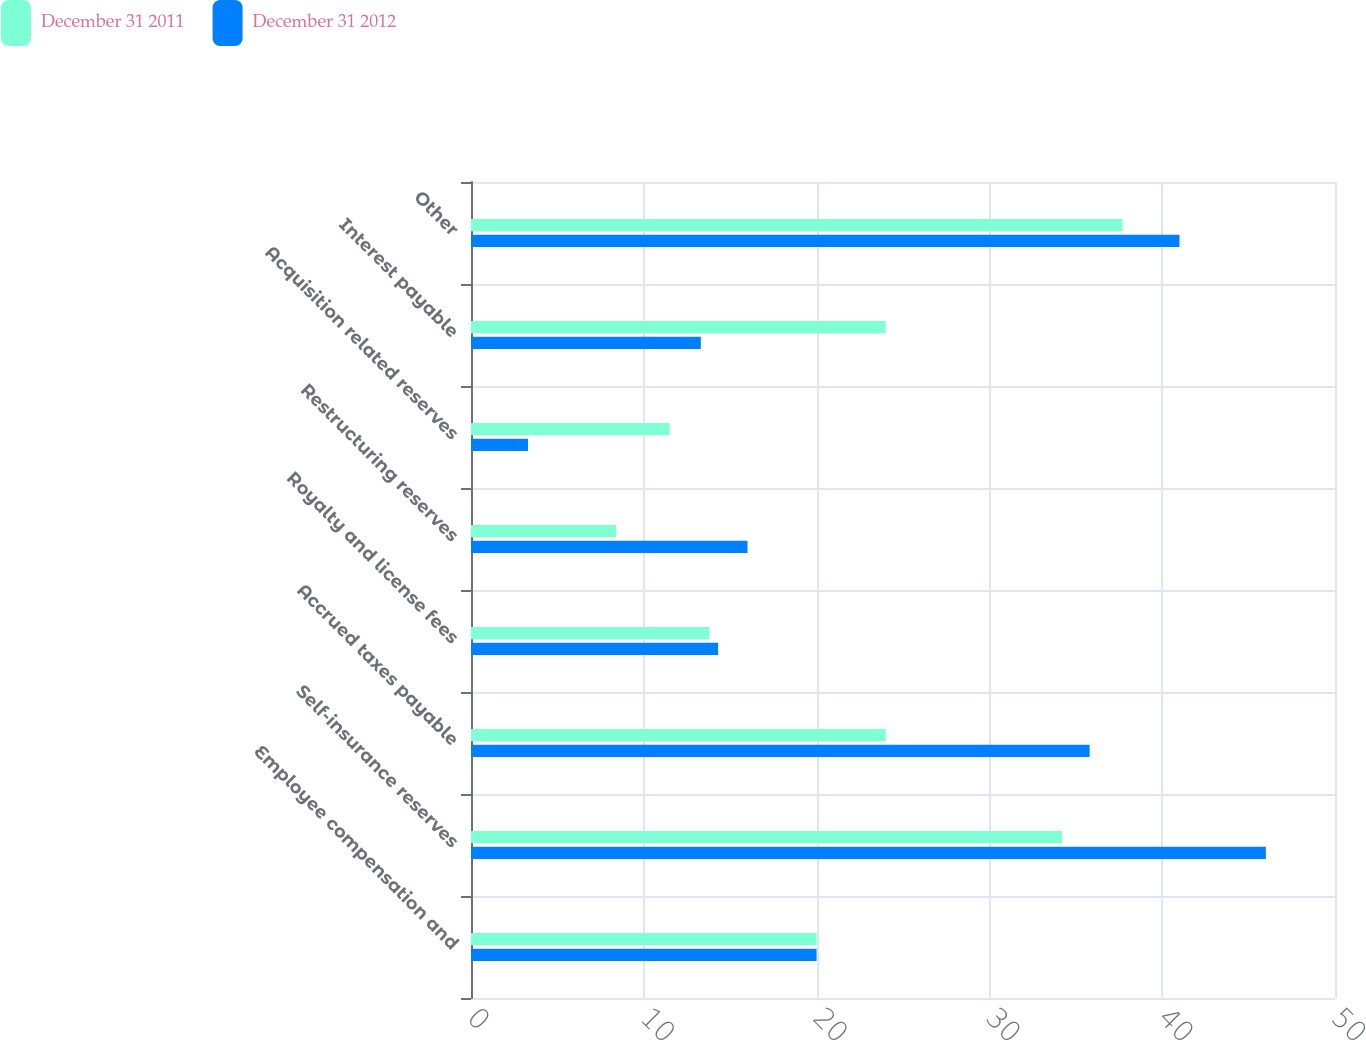Convert chart to OTSL. <chart><loc_0><loc_0><loc_500><loc_500><stacked_bar_chart><ecel><fcel>Employee compensation and<fcel>Self-insurance reserves<fcel>Accrued taxes payable<fcel>Royalty and license fees<fcel>Restructuring reserves<fcel>Acquisition related reserves<fcel>Interest payable<fcel>Other<nl><fcel>December 31 2011<fcel>20<fcel>34.2<fcel>24<fcel>13.8<fcel>8.4<fcel>11.5<fcel>24<fcel>37.7<nl><fcel>December 31 2012<fcel>20<fcel>46<fcel>35.8<fcel>14.3<fcel>16<fcel>3.3<fcel>13.3<fcel>41<nl></chart> 